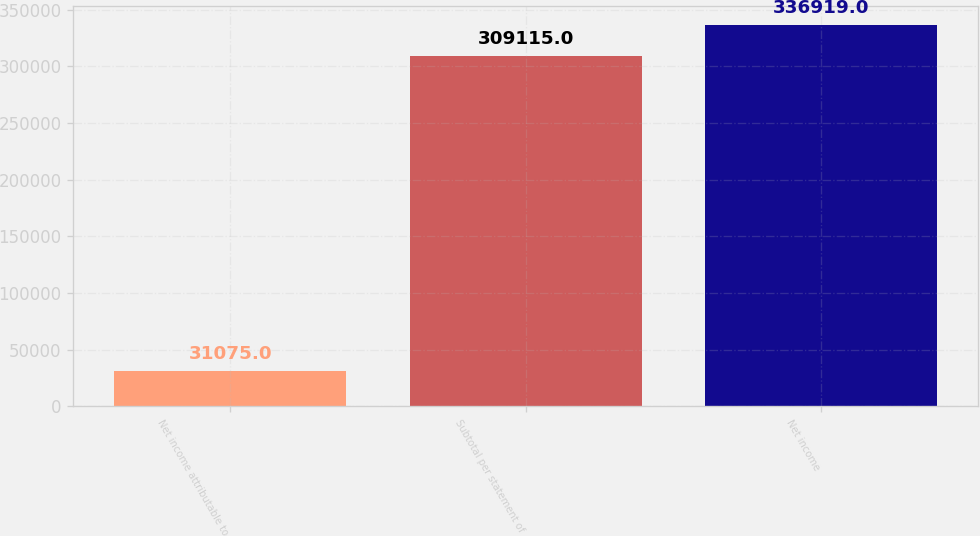Convert chart. <chart><loc_0><loc_0><loc_500><loc_500><bar_chart><fcel>Net income attributable to<fcel>Subtotal per statement of<fcel>Net income<nl><fcel>31075<fcel>309115<fcel>336919<nl></chart> 